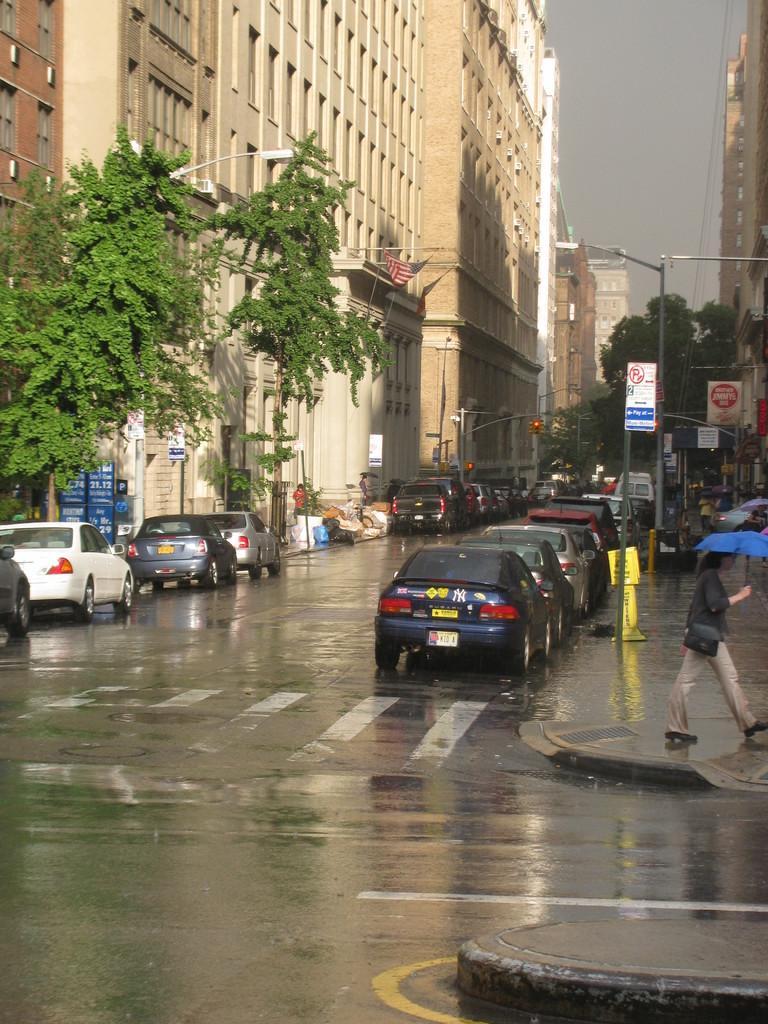Can you describe this image briefly? This picture is clicked outside the city. In this picture, we see cars parked on either side of the road. The woman in black shirt is walking in the sideways. She is holding a blue color umbrella in her hands. Behind her, we see street lights and hoarding boards. At the bottom of the picture, we see the road. On either side of the road, there are trees and buildings. In the right top of the picture, we see the sky. 